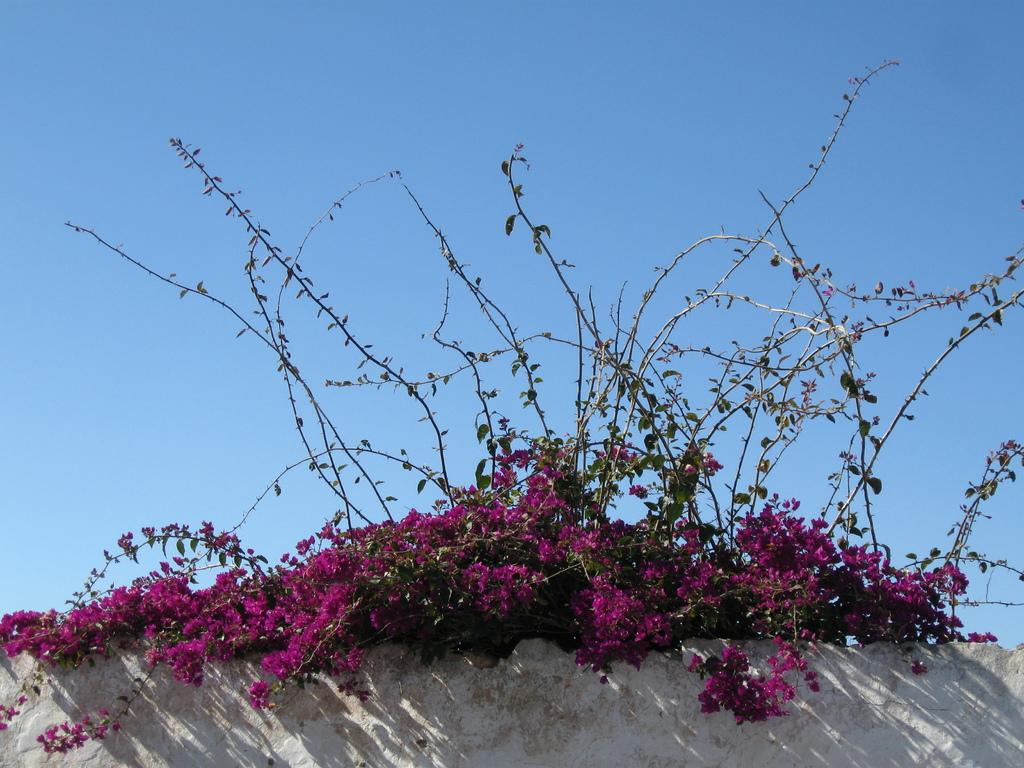What type of vegetation is present at the bottom of the image? There are flowers and plants at the bottom of the image. What structure can be seen in the image? There is a wall in the image. What is visible at the top of the image? The sky is visible at the top of the image. What type of thought can be seen floating in the liquid at the top of the image? There is no liquid or thought present in the image; it features a wall and flowers/plants at the bottom, with the sky visible at the top. 